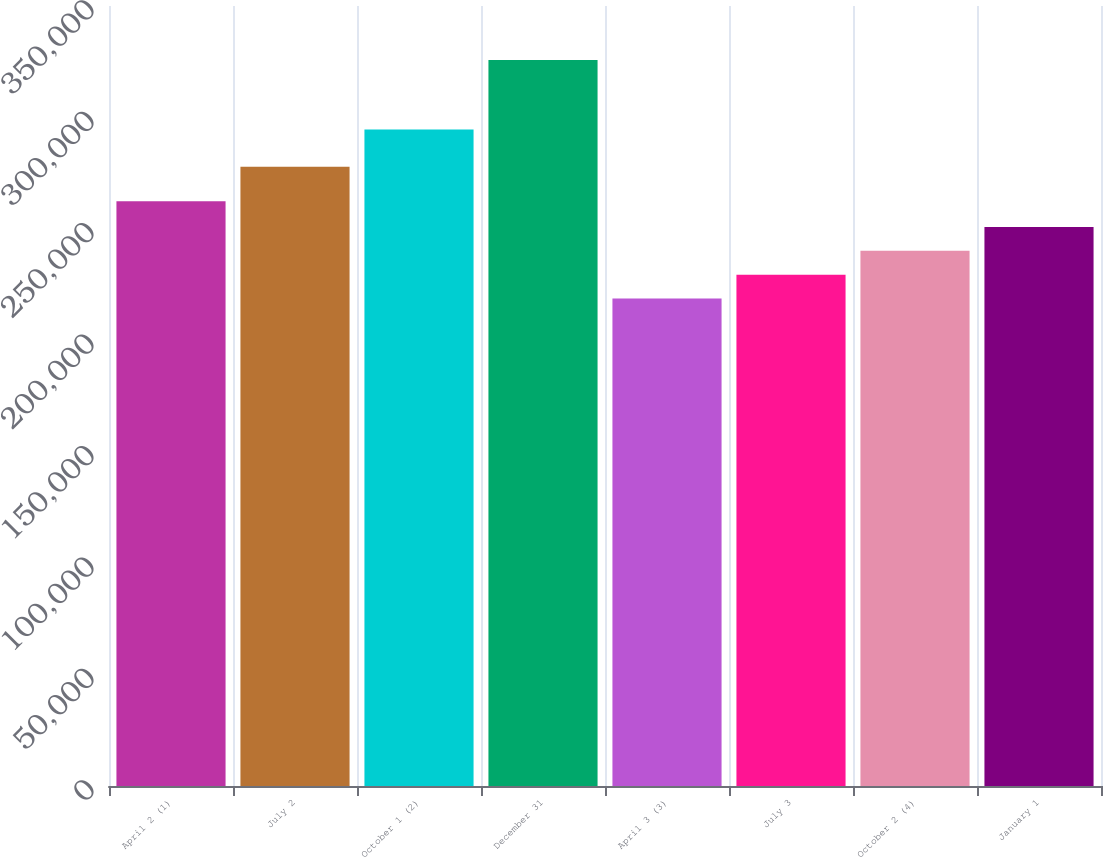Convert chart. <chart><loc_0><loc_0><loc_500><loc_500><bar_chart><fcel>April 2 (1)<fcel>July 2<fcel>October 1 (2)<fcel>December 31<fcel>April 3 (3)<fcel>July 3<fcel>October 2 (4)<fcel>January 1<nl><fcel>262354<fcel>277815<fcel>294622<fcel>325814<fcel>218728<fcel>229437<fcel>240145<fcel>250854<nl></chart> 